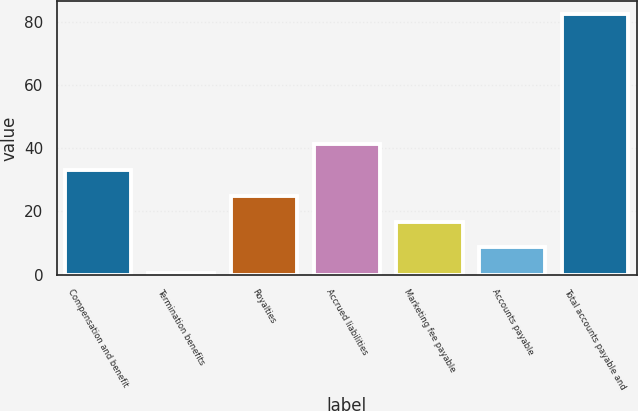Convert chart to OTSL. <chart><loc_0><loc_0><loc_500><loc_500><bar_chart><fcel>Compensation and benefit<fcel>Termination benefits<fcel>Royalties<fcel>Accrued liabilities<fcel>Marketing fee payable<fcel>Accounts payable<fcel>Total accounts payable and<nl><fcel>33.2<fcel>0.4<fcel>25<fcel>41.4<fcel>16.8<fcel>8.6<fcel>82.4<nl></chart> 